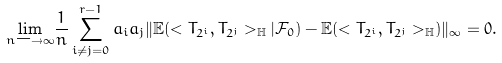<formula> <loc_0><loc_0><loc_500><loc_500>\underset { n \longrightarrow \infty } { \lim } \frac { 1 } { n } \sum _ { i \not = j = 0 } ^ { r - 1 } a _ { i } a _ { j } \| \mathbb { E } ( < T _ { 2 ^ { i } } , T _ { 2 ^ { j } } > _ { \mathbb { H } } | \mathcal { F } _ { 0 } ) - \mathbb { E } ( < T _ { 2 ^ { i } } , T _ { 2 ^ { j } } > _ { \mathbb { H } } ) \| _ { \infty } = 0 .</formula> 